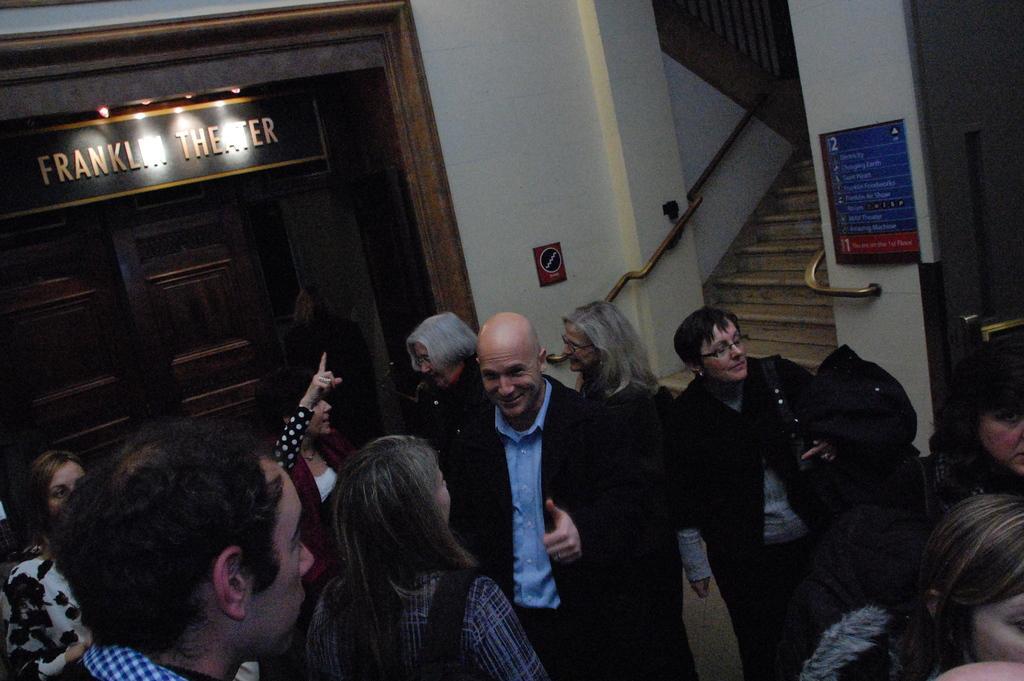In one or two sentences, can you explain what this image depicts? In this image we can see the inner view of a building and there are some people standing and in the background, we can see the door and at the top there is a board with some text. On the right side of the image we can see the stairs and there are two boards. 